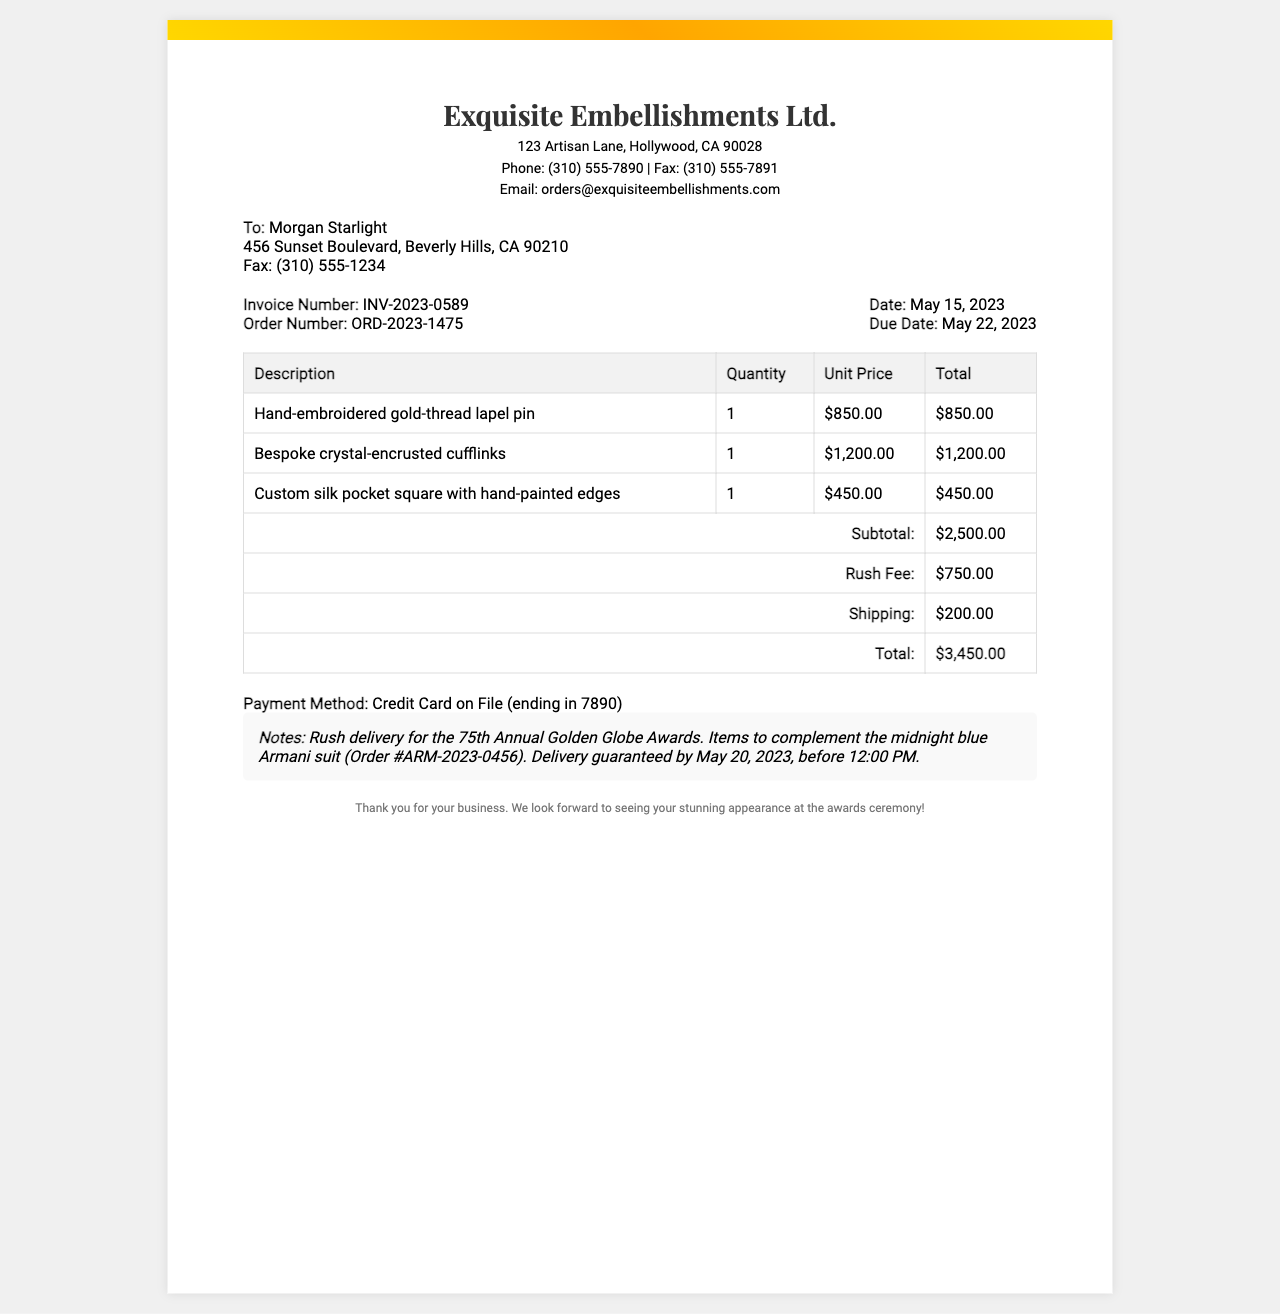What is the invoice number? The invoice number is clearly stated in the invoice section and is labeled as INV-2023-0589.
Answer: INV-2023-0589 What is the total amount due? The total amount due is the final figure calculated after adding all line items and fees, which is listed as $3,450.00.
Answer: $3,450.00 Who is the recipient of the fax? The recipient's name and address are specified at the top of the document under the recipient section.
Answer: Morgan Starlight When is the due date for payment? The document specifies a due date that is indicated as May 22, 2023.
Answer: May 22, 2023 What is the rush fee amount? The rush fee is highlighted in the invoice table, indicating the charge for expedited service, which is $750.00.
Answer: $750.00 What is the date of the invoice? The specific date when the invoice was generated is mentioned in the invoice details, which shows May 15, 2023.
Answer: May 15, 2023 What items are provided to complement the suit? The items listed in the invoice include hand-embroidered gold-thread lapel pin, bespoke crystal-encrusted cufflinks, and a custom silk pocket square.
Answer: Hand-embroidered gold-thread lapel pin, bespoke crystal-encrusted cufflinks, custom silk pocket square What is the payment method? The document specifies the method of payment used, which is identified as Credit Card on File.
Answer: Credit Card on File What event is the delivery for? The notes section mentions the purpose of the rush delivery, which is for the 75th Annual Golden Globe Awards.
Answer: 75th Annual Golden Globe Awards 